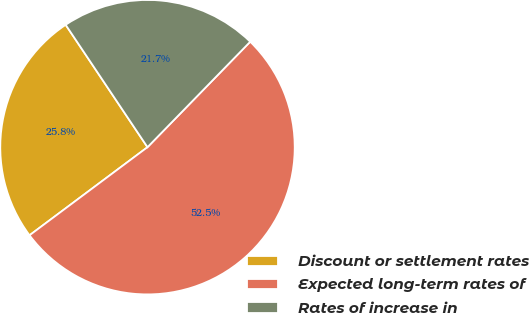Convert chart to OTSL. <chart><loc_0><loc_0><loc_500><loc_500><pie_chart><fcel>Discount or settlement rates<fcel>Expected long-term rates of<fcel>Rates of increase in<nl><fcel>25.83%<fcel>52.5%<fcel>21.67%<nl></chart> 